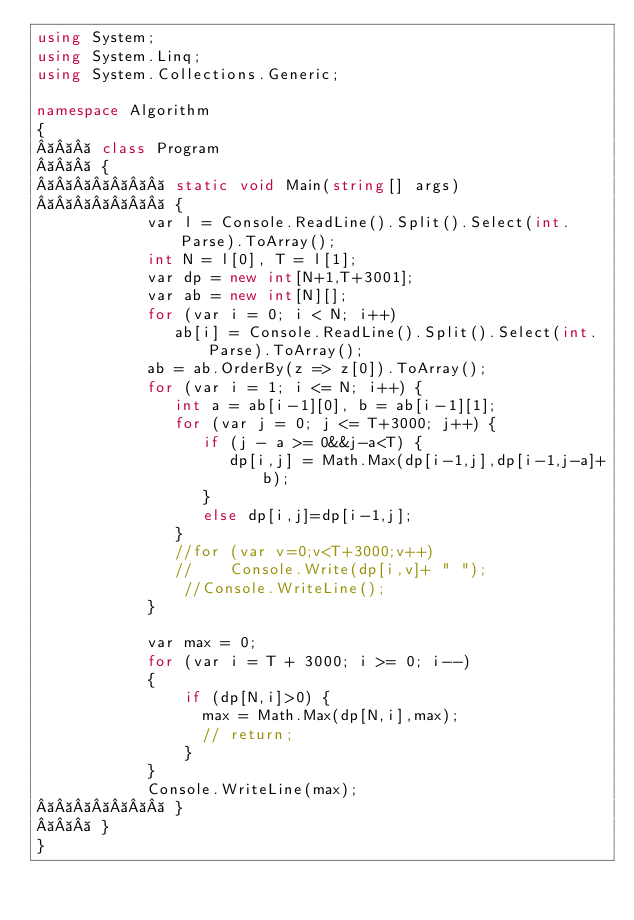<code> <loc_0><loc_0><loc_500><loc_500><_C#_>using System;
using System.Linq;
using System.Collections.Generic;

namespace Algorithm
{
    class Program
    {
        static void Main(string[] args)
        {
            var l = Console.ReadLine().Split().Select(int.Parse).ToArray();
            int N = l[0], T = l[1];
            var dp = new int[N+1,T+3001];
            var ab = new int[N][];
            for (var i = 0; i < N; i++)
               ab[i] = Console.ReadLine().Split().Select(int.Parse).ToArray();
            ab = ab.OrderBy(z => z[0]).ToArray();
            for (var i = 1; i <= N; i++) {
               int a = ab[i-1][0], b = ab[i-1][1];
               for (var j = 0; j <= T+3000; j++) {
                  if (j - a >= 0&&j-a<T) {
                     dp[i,j] = Math.Max(dp[i-1,j],dp[i-1,j-a]+b);
                  }
                  else dp[i,j]=dp[i-1,j];
               }
               //for (var v=0;v<T+3000;v++)
               //    Console.Write(dp[i,v]+ " ");
                //Console.WriteLine();
            }
            
            var max = 0;
            for (var i = T + 3000; i >= 0; i--)
            {
                if (dp[N,i]>0) {
                  max = Math.Max(dp[N,i],max);
                  // return; 
                }
            }
            Console.WriteLine(max);
        }
    }
}
</code> 